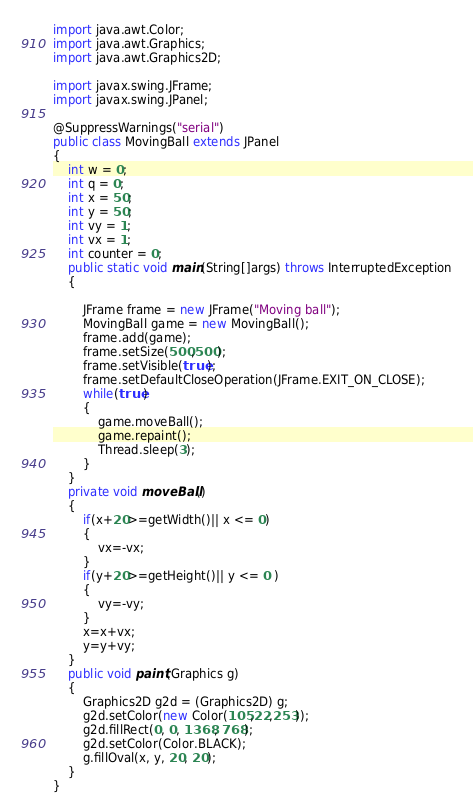Convert code to text. <code><loc_0><loc_0><loc_500><loc_500><_Java_>import java.awt.Color;
import java.awt.Graphics;
import java.awt.Graphics2D;

import javax.swing.JFrame;
import javax.swing.JPanel;

@SuppressWarnings("serial")
public class MovingBall extends JPanel
{
	int w = 0;
	int q = 0;
	int x = 50;
    int y = 50;
    int vy = 1;
    int vx = 1;
    int counter = 0;
    public static void main(String[]args) throws InterruptedException
    {
    	
        JFrame frame = new JFrame("Moving ball");
        MovingBall game = new MovingBall();
        frame.add(game);
        frame.setSize(500,500);
        frame.setVisible(true);
        frame.setDefaultCloseOperation(JFrame.EXIT_ON_CLOSE);
        while(true)
        {
            game.moveBall();
            game.repaint();
            Thread.sleep(3);
        }
    }
    private void moveBall() 
    { 
        if(x+20>=getWidth()|| x <= 0)
        {
            vx=-vx;
        }
        if(y+20>=getHeight()|| y <= 0 )
        {
            vy=-vy;
        }
        x=x+vx;
        y=y+vy;
    }
    public void paint(Graphics g)
    {
        Graphics2D g2d = (Graphics2D) g;
        g2d.setColor(new Color(105,22,253));
        g2d.fillRect(0, 0, 1368, 768);
        g2d.setColor(Color.BLACK);
        g.fillOval(x, y, 20, 20);
    }
}</code> 